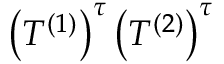<formula> <loc_0><loc_0><loc_500><loc_500>\left ( T ^ { ( 1 ) } \right ) ^ { \tau } \left ( T ^ { ( 2 ) } \right ) ^ { \tau }</formula> 